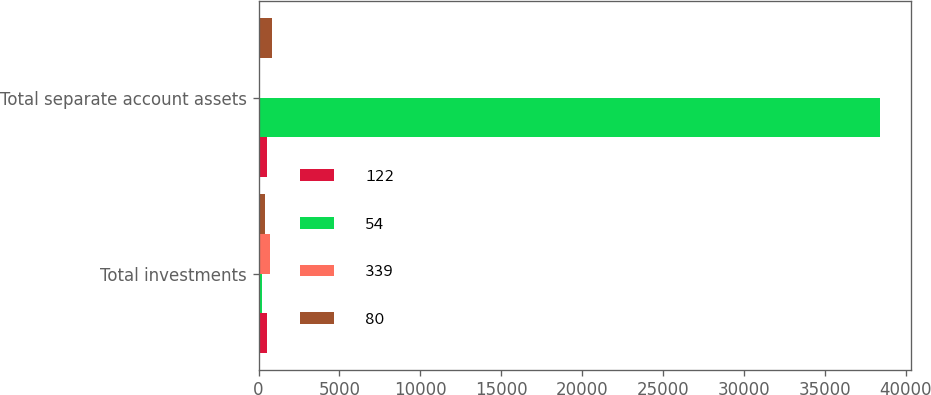Convert chart to OTSL. <chart><loc_0><loc_0><loc_500><loc_500><stacked_bar_chart><ecel><fcel>Total investments<fcel>Total separate account assets<nl><fcel>122<fcel>507<fcel>507<nl><fcel>54<fcel>193<fcel>38392<nl><fcel>339<fcel>679<fcel>2<nl><fcel>80<fcel>371<fcel>860<nl></chart> 